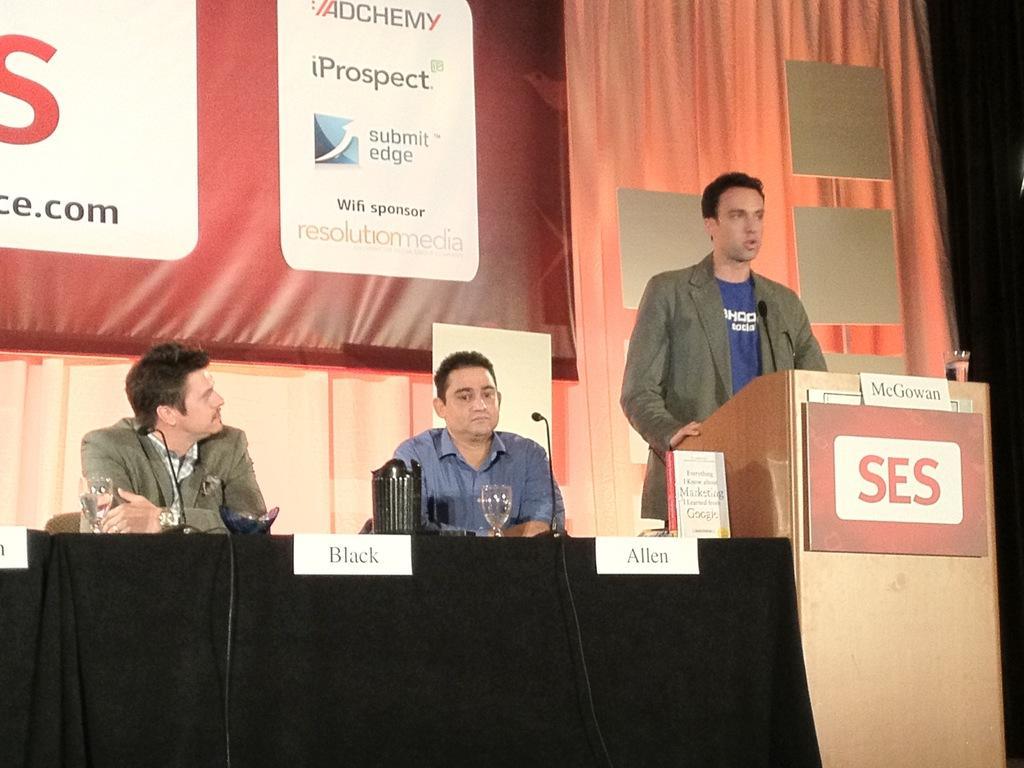Describe this image in one or two sentences. In the foreground of the picture there is a stage, on the stage there are tables, podium, people, glasses, mics, jar, nameplates and other objects. In the background there are curtains and a banner. 